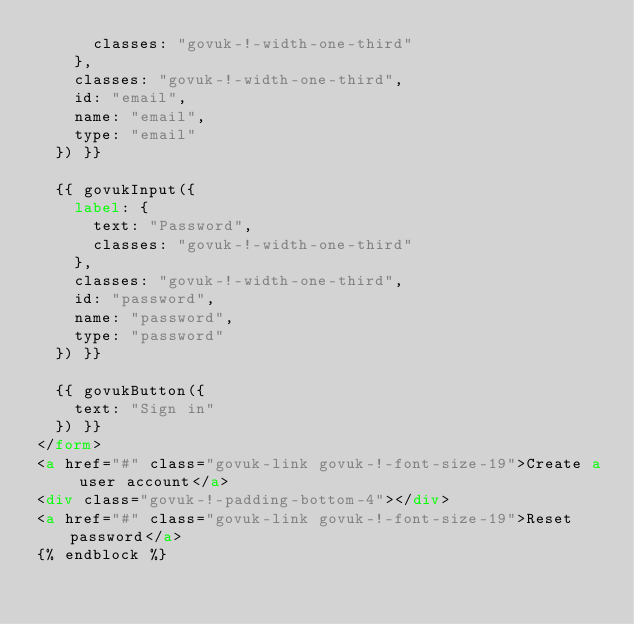<code> <loc_0><loc_0><loc_500><loc_500><_HTML_>      classes: "govuk-!-width-one-third"
    },
    classes: "govuk-!-width-one-third",
    id: "email",
    name: "email",
    type: "email"
  }) }}

  {{ govukInput({
    label: {
      text: "Password",
      classes: "govuk-!-width-one-third"
    },
    classes: "govuk-!-width-one-third",
    id: "password",
    name: "password",
    type: "password"
  }) }}

  {{ govukButton({
    text: "Sign in"
  }) }}
</form>
<a href="#" class="govuk-link govuk-!-font-size-19">Create a user account</a>
<div class="govuk-!-padding-bottom-4"></div>
<a href="#" class="govuk-link govuk-!-font-size-19">Reset password</a>
{% endblock %}</code> 